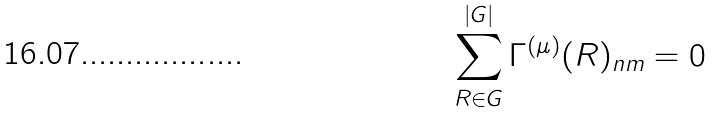Convert formula to latex. <formula><loc_0><loc_0><loc_500><loc_500>\sum _ { R \in G } ^ { | G | } \Gamma ^ { ( \mu ) } ( R ) _ { n m } = 0</formula> 